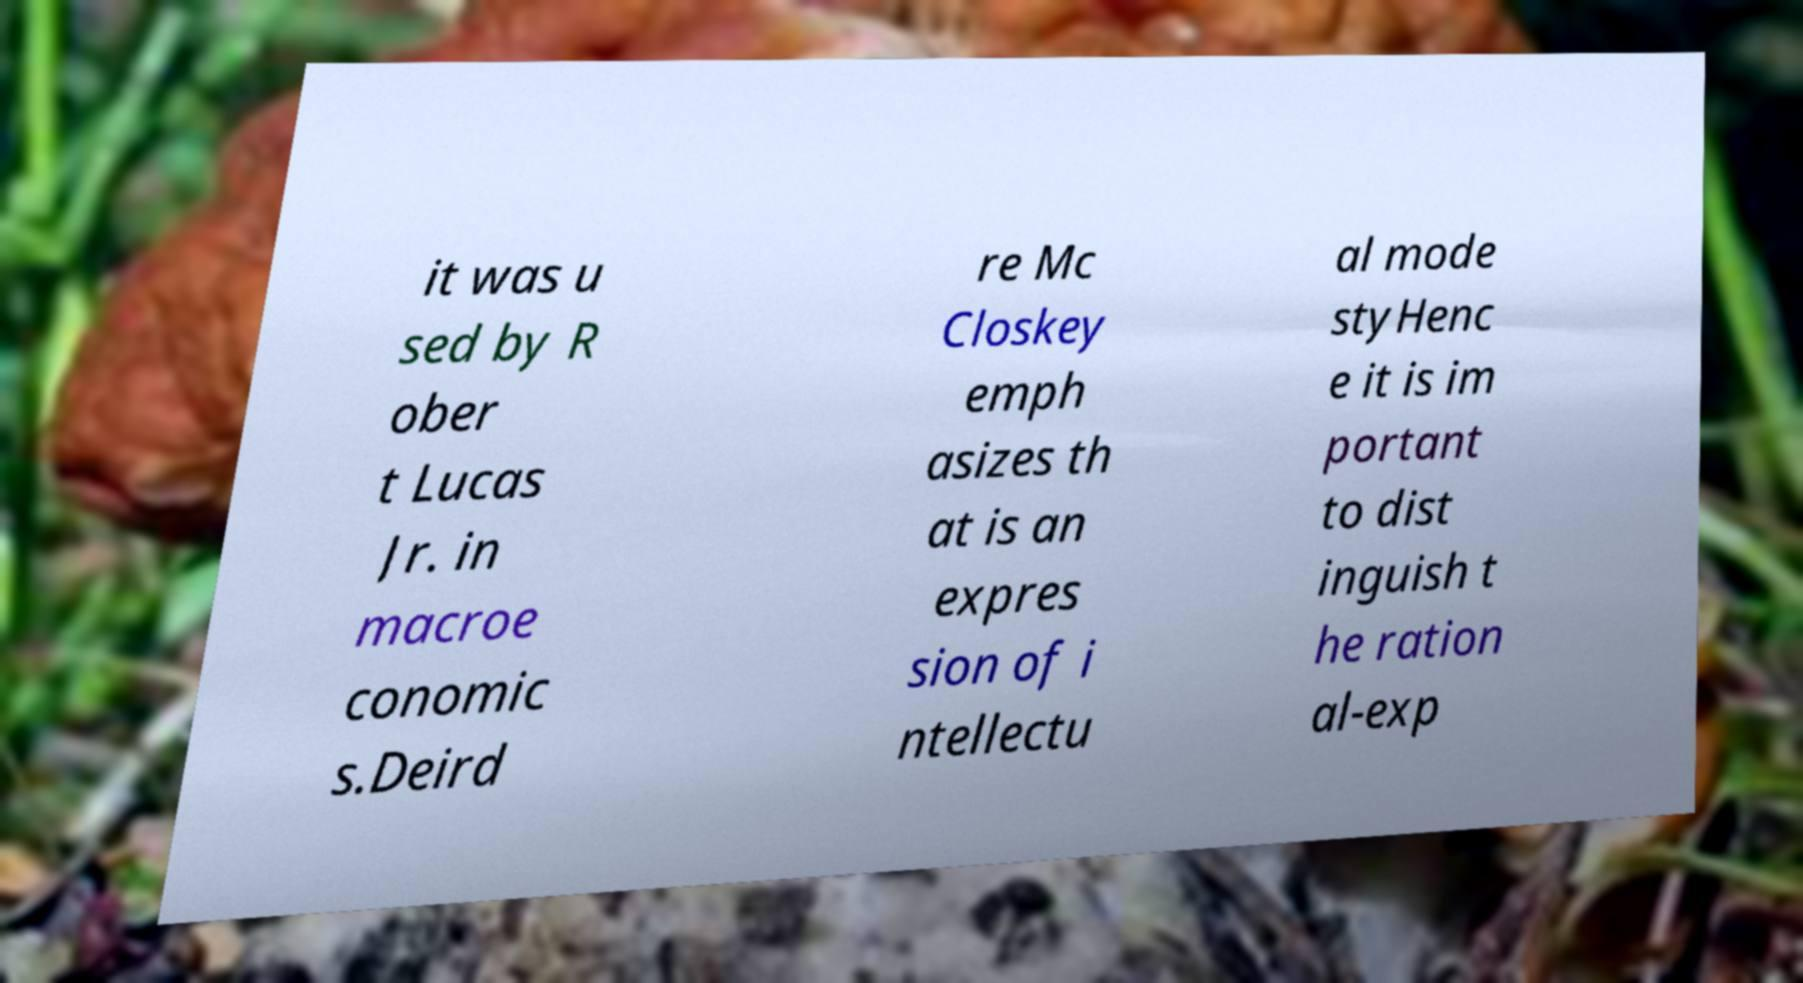Please identify and transcribe the text found in this image. it was u sed by R ober t Lucas Jr. in macroe conomic s.Deird re Mc Closkey emph asizes th at is an expres sion of i ntellectu al mode styHenc e it is im portant to dist inguish t he ration al-exp 